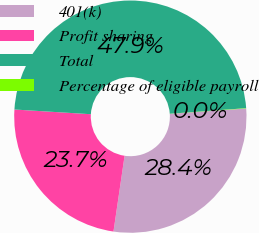Convert chart to OTSL. <chart><loc_0><loc_0><loc_500><loc_500><pie_chart><fcel>401(k)<fcel>Profit sharing<fcel>Total<fcel>Percentage of eligible payroll<nl><fcel>28.44%<fcel>23.66%<fcel>47.86%<fcel>0.04%<nl></chart> 